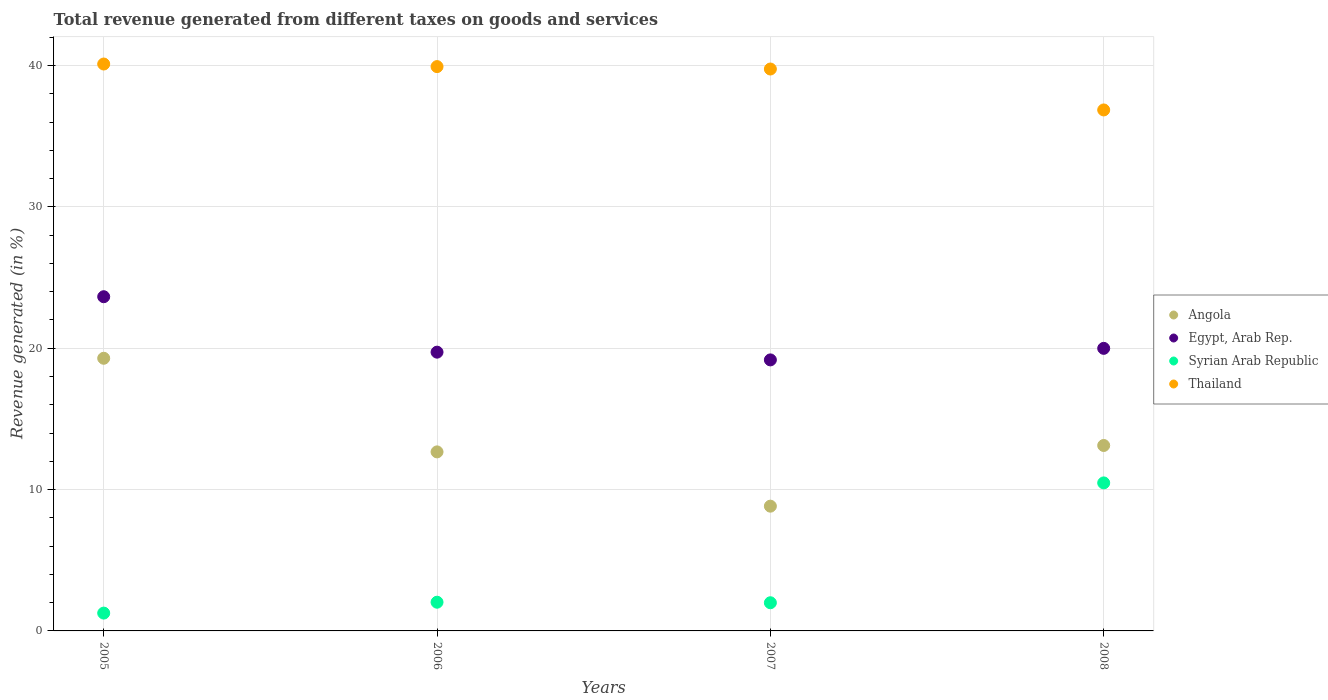Is the number of dotlines equal to the number of legend labels?
Offer a terse response. Yes. What is the total revenue generated in Egypt, Arab Rep. in 2005?
Your answer should be compact. 23.65. Across all years, what is the maximum total revenue generated in Syrian Arab Republic?
Provide a succinct answer. 10.47. Across all years, what is the minimum total revenue generated in Egypt, Arab Rep.?
Provide a succinct answer. 19.18. In which year was the total revenue generated in Angola maximum?
Your answer should be compact. 2005. What is the total total revenue generated in Angola in the graph?
Ensure brevity in your answer.  53.9. What is the difference between the total revenue generated in Thailand in 2007 and that in 2008?
Give a very brief answer. 2.9. What is the difference between the total revenue generated in Syrian Arab Republic in 2006 and the total revenue generated in Angola in 2007?
Give a very brief answer. -6.8. What is the average total revenue generated in Syrian Arab Republic per year?
Keep it short and to the point. 3.94. In the year 2006, what is the difference between the total revenue generated in Egypt, Arab Rep. and total revenue generated in Angola?
Offer a very short reply. 7.06. What is the ratio of the total revenue generated in Thailand in 2005 to that in 2008?
Provide a short and direct response. 1.09. What is the difference between the highest and the second highest total revenue generated in Syrian Arab Republic?
Make the answer very short. 8.44. What is the difference between the highest and the lowest total revenue generated in Egypt, Arab Rep.?
Give a very brief answer. 4.47. In how many years, is the total revenue generated in Thailand greater than the average total revenue generated in Thailand taken over all years?
Keep it short and to the point. 3. Is it the case that in every year, the sum of the total revenue generated in Syrian Arab Republic and total revenue generated in Egypt, Arab Rep.  is greater than the sum of total revenue generated in Angola and total revenue generated in Thailand?
Provide a short and direct response. No. Is the total revenue generated in Thailand strictly less than the total revenue generated in Egypt, Arab Rep. over the years?
Ensure brevity in your answer.  No. How many dotlines are there?
Your response must be concise. 4. Does the graph contain grids?
Provide a short and direct response. Yes. Where does the legend appear in the graph?
Offer a very short reply. Center right. How are the legend labels stacked?
Provide a succinct answer. Vertical. What is the title of the graph?
Your answer should be compact. Total revenue generated from different taxes on goods and services. Does "Venezuela" appear as one of the legend labels in the graph?
Your answer should be very brief. No. What is the label or title of the Y-axis?
Offer a terse response. Revenue generated (in %). What is the Revenue generated (in %) of Angola in 2005?
Give a very brief answer. 19.29. What is the Revenue generated (in %) of Egypt, Arab Rep. in 2005?
Provide a succinct answer. 23.65. What is the Revenue generated (in %) in Syrian Arab Republic in 2005?
Your answer should be very brief. 1.26. What is the Revenue generated (in %) in Thailand in 2005?
Provide a succinct answer. 40.11. What is the Revenue generated (in %) of Angola in 2006?
Provide a succinct answer. 12.67. What is the Revenue generated (in %) of Egypt, Arab Rep. in 2006?
Ensure brevity in your answer.  19.72. What is the Revenue generated (in %) in Syrian Arab Republic in 2006?
Keep it short and to the point. 2.03. What is the Revenue generated (in %) of Thailand in 2006?
Your response must be concise. 39.93. What is the Revenue generated (in %) of Angola in 2007?
Your answer should be compact. 8.83. What is the Revenue generated (in %) of Egypt, Arab Rep. in 2007?
Your answer should be very brief. 19.18. What is the Revenue generated (in %) in Syrian Arab Republic in 2007?
Offer a terse response. 1.99. What is the Revenue generated (in %) in Thailand in 2007?
Your answer should be compact. 39.76. What is the Revenue generated (in %) of Angola in 2008?
Your answer should be very brief. 13.12. What is the Revenue generated (in %) in Egypt, Arab Rep. in 2008?
Keep it short and to the point. 19.99. What is the Revenue generated (in %) of Syrian Arab Republic in 2008?
Your answer should be very brief. 10.47. What is the Revenue generated (in %) in Thailand in 2008?
Your answer should be compact. 36.86. Across all years, what is the maximum Revenue generated (in %) in Angola?
Keep it short and to the point. 19.29. Across all years, what is the maximum Revenue generated (in %) of Egypt, Arab Rep.?
Provide a succinct answer. 23.65. Across all years, what is the maximum Revenue generated (in %) of Syrian Arab Republic?
Provide a succinct answer. 10.47. Across all years, what is the maximum Revenue generated (in %) of Thailand?
Your response must be concise. 40.11. Across all years, what is the minimum Revenue generated (in %) in Angola?
Offer a very short reply. 8.83. Across all years, what is the minimum Revenue generated (in %) in Egypt, Arab Rep.?
Keep it short and to the point. 19.18. Across all years, what is the minimum Revenue generated (in %) of Syrian Arab Republic?
Your response must be concise. 1.26. Across all years, what is the minimum Revenue generated (in %) of Thailand?
Give a very brief answer. 36.86. What is the total Revenue generated (in %) of Angola in the graph?
Provide a succinct answer. 53.9. What is the total Revenue generated (in %) of Egypt, Arab Rep. in the graph?
Provide a succinct answer. 82.54. What is the total Revenue generated (in %) in Syrian Arab Republic in the graph?
Your response must be concise. 15.76. What is the total Revenue generated (in %) in Thailand in the graph?
Offer a very short reply. 156.65. What is the difference between the Revenue generated (in %) of Angola in 2005 and that in 2006?
Offer a terse response. 6.62. What is the difference between the Revenue generated (in %) in Egypt, Arab Rep. in 2005 and that in 2006?
Make the answer very short. 3.92. What is the difference between the Revenue generated (in %) in Syrian Arab Republic in 2005 and that in 2006?
Provide a short and direct response. -0.77. What is the difference between the Revenue generated (in %) in Thailand in 2005 and that in 2006?
Ensure brevity in your answer.  0.18. What is the difference between the Revenue generated (in %) of Angola in 2005 and that in 2007?
Offer a terse response. 10.46. What is the difference between the Revenue generated (in %) of Egypt, Arab Rep. in 2005 and that in 2007?
Ensure brevity in your answer.  4.47. What is the difference between the Revenue generated (in %) in Syrian Arab Republic in 2005 and that in 2007?
Offer a terse response. -0.73. What is the difference between the Revenue generated (in %) in Thailand in 2005 and that in 2007?
Ensure brevity in your answer.  0.35. What is the difference between the Revenue generated (in %) in Angola in 2005 and that in 2008?
Offer a terse response. 6.17. What is the difference between the Revenue generated (in %) in Egypt, Arab Rep. in 2005 and that in 2008?
Your answer should be compact. 3.65. What is the difference between the Revenue generated (in %) in Syrian Arab Republic in 2005 and that in 2008?
Provide a succinct answer. -9.21. What is the difference between the Revenue generated (in %) of Thailand in 2005 and that in 2008?
Keep it short and to the point. 3.25. What is the difference between the Revenue generated (in %) in Angola in 2006 and that in 2007?
Give a very brief answer. 3.84. What is the difference between the Revenue generated (in %) of Egypt, Arab Rep. in 2006 and that in 2007?
Your answer should be very brief. 0.55. What is the difference between the Revenue generated (in %) in Syrian Arab Republic in 2006 and that in 2007?
Your response must be concise. 0.04. What is the difference between the Revenue generated (in %) of Thailand in 2006 and that in 2007?
Offer a very short reply. 0.17. What is the difference between the Revenue generated (in %) of Angola in 2006 and that in 2008?
Give a very brief answer. -0.45. What is the difference between the Revenue generated (in %) of Egypt, Arab Rep. in 2006 and that in 2008?
Your answer should be compact. -0.27. What is the difference between the Revenue generated (in %) of Syrian Arab Republic in 2006 and that in 2008?
Provide a succinct answer. -8.44. What is the difference between the Revenue generated (in %) in Thailand in 2006 and that in 2008?
Provide a succinct answer. 3.07. What is the difference between the Revenue generated (in %) in Angola in 2007 and that in 2008?
Offer a terse response. -4.29. What is the difference between the Revenue generated (in %) of Egypt, Arab Rep. in 2007 and that in 2008?
Your answer should be compact. -0.82. What is the difference between the Revenue generated (in %) in Syrian Arab Republic in 2007 and that in 2008?
Make the answer very short. -8.48. What is the difference between the Revenue generated (in %) of Thailand in 2007 and that in 2008?
Your response must be concise. 2.9. What is the difference between the Revenue generated (in %) of Angola in 2005 and the Revenue generated (in %) of Egypt, Arab Rep. in 2006?
Give a very brief answer. -0.43. What is the difference between the Revenue generated (in %) in Angola in 2005 and the Revenue generated (in %) in Syrian Arab Republic in 2006?
Give a very brief answer. 17.26. What is the difference between the Revenue generated (in %) in Angola in 2005 and the Revenue generated (in %) in Thailand in 2006?
Ensure brevity in your answer.  -20.64. What is the difference between the Revenue generated (in %) in Egypt, Arab Rep. in 2005 and the Revenue generated (in %) in Syrian Arab Republic in 2006?
Your answer should be very brief. 21.61. What is the difference between the Revenue generated (in %) of Egypt, Arab Rep. in 2005 and the Revenue generated (in %) of Thailand in 2006?
Ensure brevity in your answer.  -16.28. What is the difference between the Revenue generated (in %) of Syrian Arab Republic in 2005 and the Revenue generated (in %) of Thailand in 2006?
Keep it short and to the point. -38.67. What is the difference between the Revenue generated (in %) in Angola in 2005 and the Revenue generated (in %) in Egypt, Arab Rep. in 2007?
Offer a terse response. 0.12. What is the difference between the Revenue generated (in %) in Angola in 2005 and the Revenue generated (in %) in Syrian Arab Republic in 2007?
Provide a short and direct response. 17.3. What is the difference between the Revenue generated (in %) of Angola in 2005 and the Revenue generated (in %) of Thailand in 2007?
Your response must be concise. -20.47. What is the difference between the Revenue generated (in %) in Egypt, Arab Rep. in 2005 and the Revenue generated (in %) in Syrian Arab Republic in 2007?
Provide a short and direct response. 21.65. What is the difference between the Revenue generated (in %) of Egypt, Arab Rep. in 2005 and the Revenue generated (in %) of Thailand in 2007?
Ensure brevity in your answer.  -16.11. What is the difference between the Revenue generated (in %) in Syrian Arab Republic in 2005 and the Revenue generated (in %) in Thailand in 2007?
Give a very brief answer. -38.49. What is the difference between the Revenue generated (in %) of Angola in 2005 and the Revenue generated (in %) of Egypt, Arab Rep. in 2008?
Ensure brevity in your answer.  -0.7. What is the difference between the Revenue generated (in %) of Angola in 2005 and the Revenue generated (in %) of Syrian Arab Republic in 2008?
Your response must be concise. 8.82. What is the difference between the Revenue generated (in %) in Angola in 2005 and the Revenue generated (in %) in Thailand in 2008?
Give a very brief answer. -17.57. What is the difference between the Revenue generated (in %) of Egypt, Arab Rep. in 2005 and the Revenue generated (in %) of Syrian Arab Republic in 2008?
Make the answer very short. 13.17. What is the difference between the Revenue generated (in %) of Egypt, Arab Rep. in 2005 and the Revenue generated (in %) of Thailand in 2008?
Offer a terse response. -13.21. What is the difference between the Revenue generated (in %) of Syrian Arab Republic in 2005 and the Revenue generated (in %) of Thailand in 2008?
Your answer should be very brief. -35.6. What is the difference between the Revenue generated (in %) in Angola in 2006 and the Revenue generated (in %) in Egypt, Arab Rep. in 2007?
Your answer should be very brief. -6.51. What is the difference between the Revenue generated (in %) in Angola in 2006 and the Revenue generated (in %) in Syrian Arab Republic in 2007?
Your answer should be compact. 10.67. What is the difference between the Revenue generated (in %) in Angola in 2006 and the Revenue generated (in %) in Thailand in 2007?
Keep it short and to the point. -27.09. What is the difference between the Revenue generated (in %) in Egypt, Arab Rep. in 2006 and the Revenue generated (in %) in Syrian Arab Republic in 2007?
Keep it short and to the point. 17.73. What is the difference between the Revenue generated (in %) in Egypt, Arab Rep. in 2006 and the Revenue generated (in %) in Thailand in 2007?
Offer a very short reply. -20.03. What is the difference between the Revenue generated (in %) in Syrian Arab Republic in 2006 and the Revenue generated (in %) in Thailand in 2007?
Make the answer very short. -37.73. What is the difference between the Revenue generated (in %) of Angola in 2006 and the Revenue generated (in %) of Egypt, Arab Rep. in 2008?
Provide a short and direct response. -7.32. What is the difference between the Revenue generated (in %) of Angola in 2006 and the Revenue generated (in %) of Syrian Arab Republic in 2008?
Your answer should be very brief. 2.19. What is the difference between the Revenue generated (in %) in Angola in 2006 and the Revenue generated (in %) in Thailand in 2008?
Keep it short and to the point. -24.19. What is the difference between the Revenue generated (in %) of Egypt, Arab Rep. in 2006 and the Revenue generated (in %) of Syrian Arab Republic in 2008?
Ensure brevity in your answer.  9.25. What is the difference between the Revenue generated (in %) in Egypt, Arab Rep. in 2006 and the Revenue generated (in %) in Thailand in 2008?
Make the answer very short. -17.14. What is the difference between the Revenue generated (in %) of Syrian Arab Republic in 2006 and the Revenue generated (in %) of Thailand in 2008?
Make the answer very short. -34.83. What is the difference between the Revenue generated (in %) in Angola in 2007 and the Revenue generated (in %) in Egypt, Arab Rep. in 2008?
Give a very brief answer. -11.17. What is the difference between the Revenue generated (in %) of Angola in 2007 and the Revenue generated (in %) of Syrian Arab Republic in 2008?
Your answer should be compact. -1.65. What is the difference between the Revenue generated (in %) of Angola in 2007 and the Revenue generated (in %) of Thailand in 2008?
Keep it short and to the point. -28.03. What is the difference between the Revenue generated (in %) in Egypt, Arab Rep. in 2007 and the Revenue generated (in %) in Syrian Arab Republic in 2008?
Make the answer very short. 8.7. What is the difference between the Revenue generated (in %) in Egypt, Arab Rep. in 2007 and the Revenue generated (in %) in Thailand in 2008?
Provide a succinct answer. -17.68. What is the difference between the Revenue generated (in %) of Syrian Arab Republic in 2007 and the Revenue generated (in %) of Thailand in 2008?
Ensure brevity in your answer.  -34.87. What is the average Revenue generated (in %) in Angola per year?
Your answer should be very brief. 13.48. What is the average Revenue generated (in %) of Egypt, Arab Rep. per year?
Ensure brevity in your answer.  20.63. What is the average Revenue generated (in %) of Syrian Arab Republic per year?
Offer a very short reply. 3.94. What is the average Revenue generated (in %) of Thailand per year?
Offer a very short reply. 39.16. In the year 2005, what is the difference between the Revenue generated (in %) of Angola and Revenue generated (in %) of Egypt, Arab Rep.?
Offer a terse response. -4.36. In the year 2005, what is the difference between the Revenue generated (in %) of Angola and Revenue generated (in %) of Syrian Arab Republic?
Ensure brevity in your answer.  18.03. In the year 2005, what is the difference between the Revenue generated (in %) in Angola and Revenue generated (in %) in Thailand?
Your response must be concise. -20.82. In the year 2005, what is the difference between the Revenue generated (in %) in Egypt, Arab Rep. and Revenue generated (in %) in Syrian Arab Republic?
Offer a terse response. 22.38. In the year 2005, what is the difference between the Revenue generated (in %) of Egypt, Arab Rep. and Revenue generated (in %) of Thailand?
Keep it short and to the point. -16.46. In the year 2005, what is the difference between the Revenue generated (in %) of Syrian Arab Republic and Revenue generated (in %) of Thailand?
Keep it short and to the point. -38.85. In the year 2006, what is the difference between the Revenue generated (in %) of Angola and Revenue generated (in %) of Egypt, Arab Rep.?
Your response must be concise. -7.06. In the year 2006, what is the difference between the Revenue generated (in %) in Angola and Revenue generated (in %) in Syrian Arab Republic?
Keep it short and to the point. 10.64. In the year 2006, what is the difference between the Revenue generated (in %) of Angola and Revenue generated (in %) of Thailand?
Give a very brief answer. -27.26. In the year 2006, what is the difference between the Revenue generated (in %) of Egypt, Arab Rep. and Revenue generated (in %) of Syrian Arab Republic?
Your response must be concise. 17.69. In the year 2006, what is the difference between the Revenue generated (in %) of Egypt, Arab Rep. and Revenue generated (in %) of Thailand?
Offer a very short reply. -20.2. In the year 2006, what is the difference between the Revenue generated (in %) of Syrian Arab Republic and Revenue generated (in %) of Thailand?
Your answer should be very brief. -37.9. In the year 2007, what is the difference between the Revenue generated (in %) of Angola and Revenue generated (in %) of Egypt, Arab Rep.?
Offer a terse response. -10.35. In the year 2007, what is the difference between the Revenue generated (in %) of Angola and Revenue generated (in %) of Syrian Arab Republic?
Make the answer very short. 6.83. In the year 2007, what is the difference between the Revenue generated (in %) in Angola and Revenue generated (in %) in Thailand?
Ensure brevity in your answer.  -30.93. In the year 2007, what is the difference between the Revenue generated (in %) in Egypt, Arab Rep. and Revenue generated (in %) in Syrian Arab Republic?
Make the answer very short. 17.18. In the year 2007, what is the difference between the Revenue generated (in %) in Egypt, Arab Rep. and Revenue generated (in %) in Thailand?
Offer a very short reply. -20.58. In the year 2007, what is the difference between the Revenue generated (in %) in Syrian Arab Republic and Revenue generated (in %) in Thailand?
Give a very brief answer. -37.76. In the year 2008, what is the difference between the Revenue generated (in %) of Angola and Revenue generated (in %) of Egypt, Arab Rep.?
Provide a succinct answer. -6.87. In the year 2008, what is the difference between the Revenue generated (in %) of Angola and Revenue generated (in %) of Syrian Arab Republic?
Make the answer very short. 2.65. In the year 2008, what is the difference between the Revenue generated (in %) of Angola and Revenue generated (in %) of Thailand?
Ensure brevity in your answer.  -23.74. In the year 2008, what is the difference between the Revenue generated (in %) of Egypt, Arab Rep. and Revenue generated (in %) of Syrian Arab Republic?
Your response must be concise. 9.52. In the year 2008, what is the difference between the Revenue generated (in %) in Egypt, Arab Rep. and Revenue generated (in %) in Thailand?
Your response must be concise. -16.87. In the year 2008, what is the difference between the Revenue generated (in %) in Syrian Arab Republic and Revenue generated (in %) in Thailand?
Ensure brevity in your answer.  -26.39. What is the ratio of the Revenue generated (in %) of Angola in 2005 to that in 2006?
Your answer should be very brief. 1.52. What is the ratio of the Revenue generated (in %) of Egypt, Arab Rep. in 2005 to that in 2006?
Provide a short and direct response. 1.2. What is the ratio of the Revenue generated (in %) of Syrian Arab Republic in 2005 to that in 2006?
Ensure brevity in your answer.  0.62. What is the ratio of the Revenue generated (in %) in Angola in 2005 to that in 2007?
Keep it short and to the point. 2.19. What is the ratio of the Revenue generated (in %) in Egypt, Arab Rep. in 2005 to that in 2007?
Provide a short and direct response. 1.23. What is the ratio of the Revenue generated (in %) in Syrian Arab Republic in 2005 to that in 2007?
Provide a short and direct response. 0.63. What is the ratio of the Revenue generated (in %) in Thailand in 2005 to that in 2007?
Offer a very short reply. 1.01. What is the ratio of the Revenue generated (in %) of Angola in 2005 to that in 2008?
Your response must be concise. 1.47. What is the ratio of the Revenue generated (in %) of Egypt, Arab Rep. in 2005 to that in 2008?
Your answer should be compact. 1.18. What is the ratio of the Revenue generated (in %) of Syrian Arab Republic in 2005 to that in 2008?
Keep it short and to the point. 0.12. What is the ratio of the Revenue generated (in %) of Thailand in 2005 to that in 2008?
Provide a succinct answer. 1.09. What is the ratio of the Revenue generated (in %) in Angola in 2006 to that in 2007?
Give a very brief answer. 1.44. What is the ratio of the Revenue generated (in %) of Egypt, Arab Rep. in 2006 to that in 2007?
Offer a terse response. 1.03. What is the ratio of the Revenue generated (in %) of Thailand in 2006 to that in 2007?
Keep it short and to the point. 1. What is the ratio of the Revenue generated (in %) of Angola in 2006 to that in 2008?
Your response must be concise. 0.97. What is the ratio of the Revenue generated (in %) of Egypt, Arab Rep. in 2006 to that in 2008?
Make the answer very short. 0.99. What is the ratio of the Revenue generated (in %) of Syrian Arab Republic in 2006 to that in 2008?
Your answer should be compact. 0.19. What is the ratio of the Revenue generated (in %) of Thailand in 2006 to that in 2008?
Make the answer very short. 1.08. What is the ratio of the Revenue generated (in %) in Angola in 2007 to that in 2008?
Provide a short and direct response. 0.67. What is the ratio of the Revenue generated (in %) in Egypt, Arab Rep. in 2007 to that in 2008?
Offer a terse response. 0.96. What is the ratio of the Revenue generated (in %) in Syrian Arab Republic in 2007 to that in 2008?
Offer a terse response. 0.19. What is the ratio of the Revenue generated (in %) of Thailand in 2007 to that in 2008?
Make the answer very short. 1.08. What is the difference between the highest and the second highest Revenue generated (in %) in Angola?
Offer a terse response. 6.17. What is the difference between the highest and the second highest Revenue generated (in %) in Egypt, Arab Rep.?
Make the answer very short. 3.65. What is the difference between the highest and the second highest Revenue generated (in %) of Syrian Arab Republic?
Your response must be concise. 8.44. What is the difference between the highest and the second highest Revenue generated (in %) in Thailand?
Offer a very short reply. 0.18. What is the difference between the highest and the lowest Revenue generated (in %) in Angola?
Offer a very short reply. 10.46. What is the difference between the highest and the lowest Revenue generated (in %) in Egypt, Arab Rep.?
Your response must be concise. 4.47. What is the difference between the highest and the lowest Revenue generated (in %) of Syrian Arab Republic?
Make the answer very short. 9.21. What is the difference between the highest and the lowest Revenue generated (in %) in Thailand?
Ensure brevity in your answer.  3.25. 